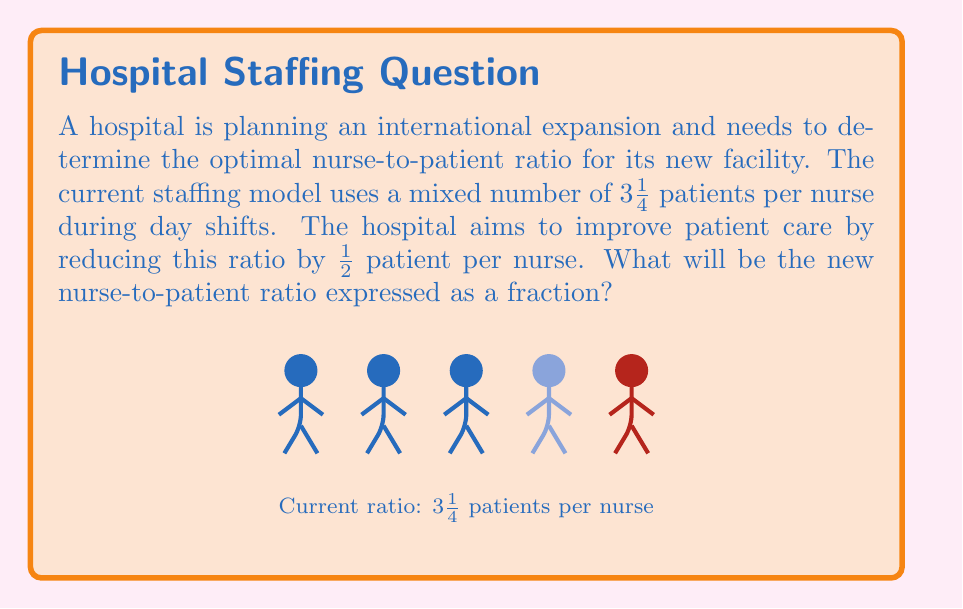Teach me how to tackle this problem. Let's approach this step-by-step:

1) First, we need to convert the mixed number $3\frac{1}{4}$ to an improper fraction:
   $$3\frac{1}{4} = \frac{13}{4}$$
   This is because $3 * 4 + 1 = 13$.

2) Now, we need to reduce this ratio by $\frac{1}{2}$ patient per nurse:
   $$\frac{13}{4} - \frac{1}{2} = \frac{13}{4} - \frac{2}{4} = \frac{11}{4}$$

3) To simplify this fraction, we need to check if there are any common factors between 11 and 4:
   11 and 4 have no common factors other than 1, so $\frac{11}{4}$ is already in its simplest form.

4) Therefore, the new nurse-to-patient ratio is $\frac{11}{4}$ patients per nurse.

5) To interpret this result: For every 4 nurses, there should be 11 patients, which is indeed a reduction from the original 13 patients per 4 nurses.
Answer: $\frac{11}{4}$ 